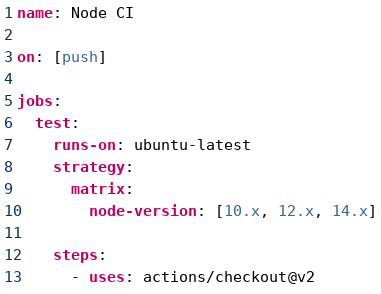Convert code to text. <code><loc_0><loc_0><loc_500><loc_500><_YAML_>name: Node CI

on: [push]

jobs:
  test:
    runs-on: ubuntu-latest
    strategy:
      matrix:
        node-version: [10.x, 12.x, 14.x]

    steps:
      - uses: actions/checkout@v2
</code> 